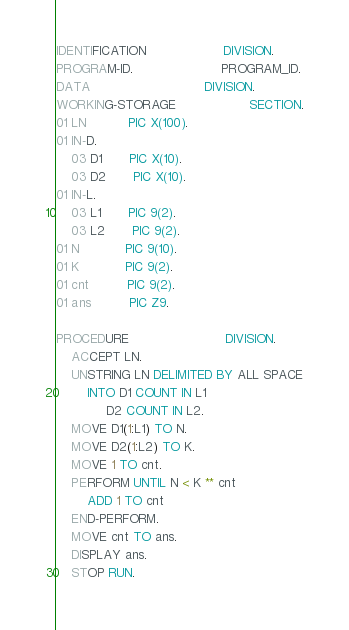<code> <loc_0><loc_0><loc_500><loc_500><_COBOL_>IDENTIFICATION                    DIVISION.
PROGRAM-ID.                       PROGRAM_ID.
DATA                              DIVISION.
WORKING-STORAGE                   SECTION.
01 LN           PIC X(100).
01 IN-D.
    03 D1       PIC X(10).
    03 D2       PIC X(10).
01 IN-L.
    03 L1       PIC 9(2).
    03 L2       PIC 9(2).
01 N            PIC 9(10).
01 K            PIC 9(2).
01 cnt          PIC 9(2).
01 ans          PIC Z9.

PROCEDURE                         DIVISION.
    ACCEPT LN.
    UNSTRING LN DELIMITED BY ALL SPACE
        INTO D1 COUNT IN L1
             D2 COUNT IN L2.
    MOVE D1(1:L1) TO N.
    MOVE D2(1:L2) TO K.
    MOVE 1 TO cnt.
    PERFORM UNTIL N < K ** cnt
        ADD 1 TO cnt
    END-PERFORM.
    MOVE cnt TO ans.
    DISPLAY ans.
    STOP RUN.
</code> 